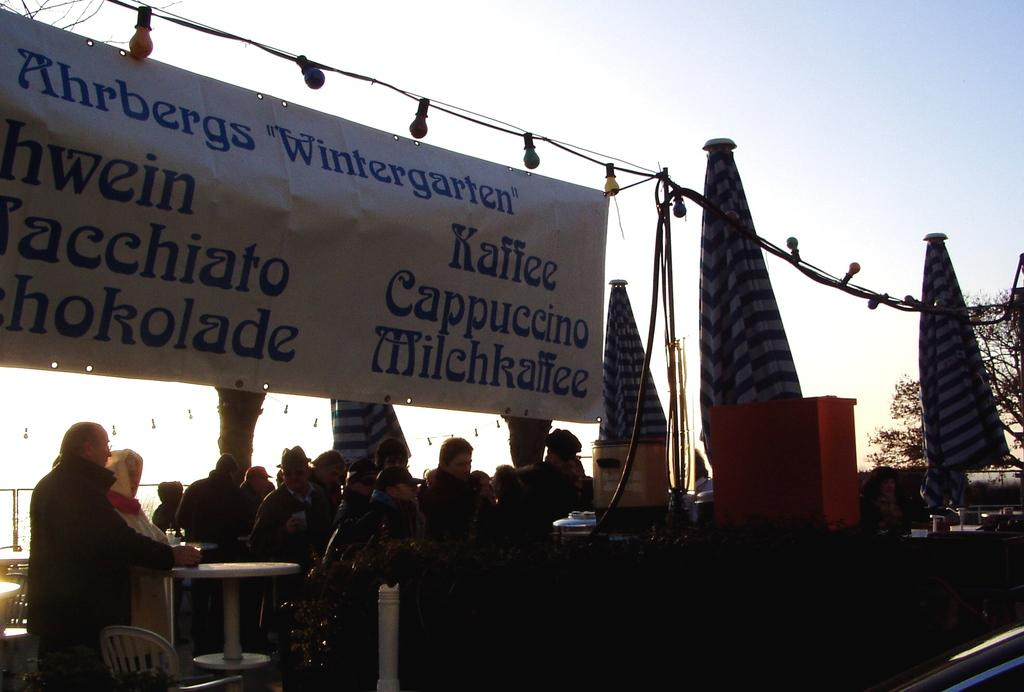What can be seen in the background of the image? There is a sky in the image. What is hanging or displayed in the image? There is a banner in the image. What are the people in the image doing? The people in the image are standing and sitting. What piece of furniture is present in the image? There is a table in the image. What type of egg is being used to cut the banner in the image? There is no egg or blade present in the image, and therefore no such activity can be observed. 